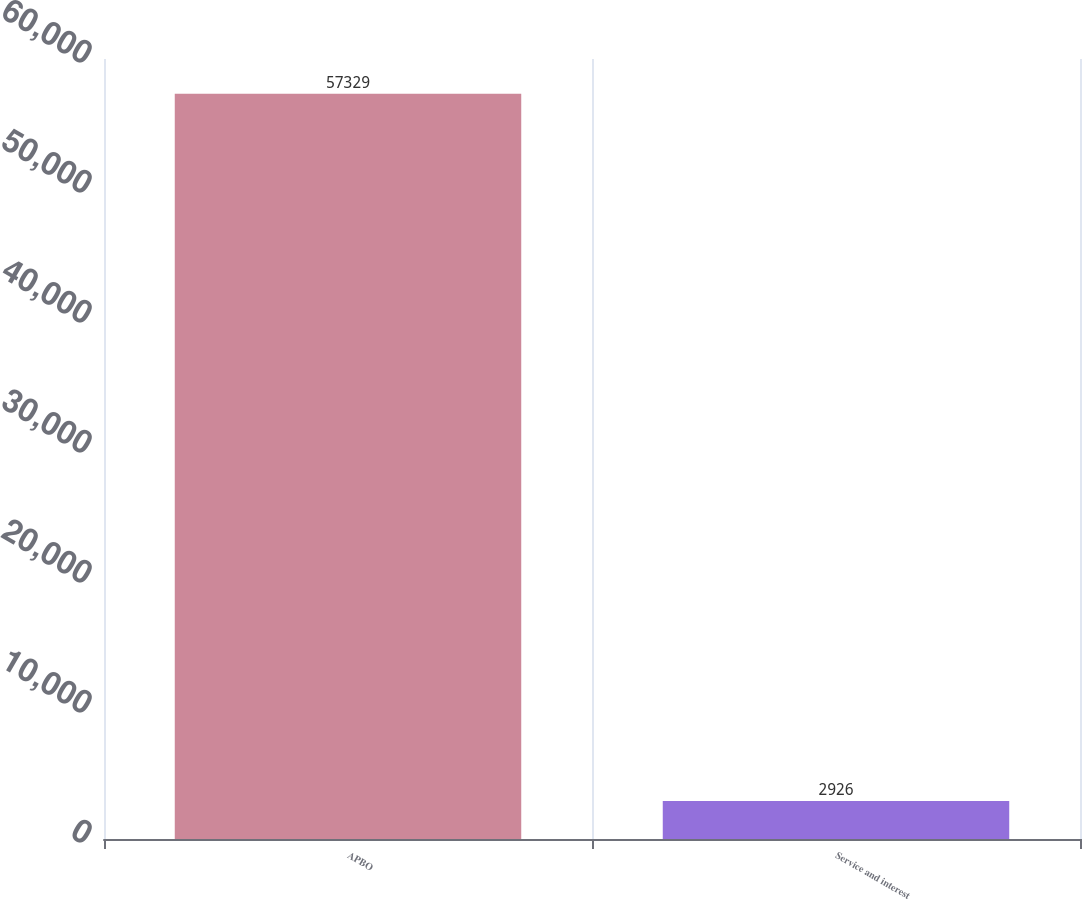Convert chart to OTSL. <chart><loc_0><loc_0><loc_500><loc_500><bar_chart><fcel>APBO<fcel>Service and interest<nl><fcel>57329<fcel>2926<nl></chart> 